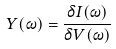<formula> <loc_0><loc_0><loc_500><loc_500>Y ( \omega ) = \frac { \delta I ( \omega ) } { \delta V ( \omega ) }</formula> 